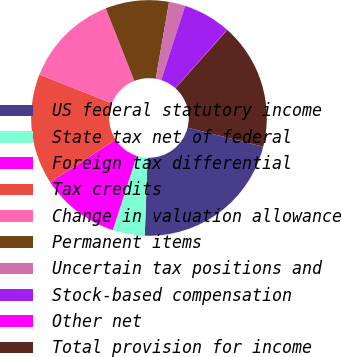<chart> <loc_0><loc_0><loc_500><loc_500><pie_chart><fcel>US federal statutory income<fcel>State tax net of federal<fcel>Foreign tax differential<fcel>Tax credits<fcel>Change in valuation allowance<fcel>Permanent items<fcel>Uncertain tax positions and<fcel>Stock-based compensation<fcel>Other net<fcel>Total provision for income<nl><fcel>21.64%<fcel>4.39%<fcel>10.86%<fcel>15.18%<fcel>13.02%<fcel>8.71%<fcel>2.23%<fcel>6.55%<fcel>0.07%<fcel>17.34%<nl></chart> 